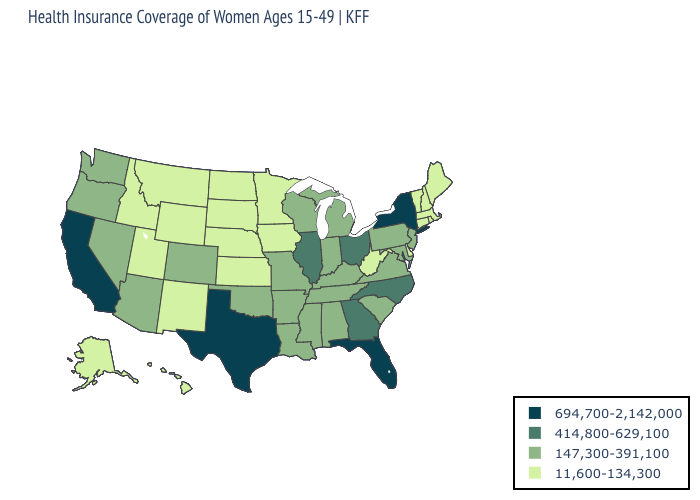Does Florida have the highest value in the South?
Be succinct. Yes. What is the value of Hawaii?
Short answer required. 11,600-134,300. Does Tennessee have the highest value in the South?
Short answer required. No. Does Illinois have a lower value than South Carolina?
Keep it brief. No. Does Maine have a lower value than Illinois?
Answer briefly. Yes. Does South Carolina have the lowest value in the South?
Keep it brief. No. Name the states that have a value in the range 11,600-134,300?
Short answer required. Alaska, Connecticut, Delaware, Hawaii, Idaho, Iowa, Kansas, Maine, Massachusetts, Minnesota, Montana, Nebraska, New Hampshire, New Mexico, North Dakota, Rhode Island, South Dakota, Utah, Vermont, West Virginia, Wyoming. Name the states that have a value in the range 147,300-391,100?
Quick response, please. Alabama, Arizona, Arkansas, Colorado, Indiana, Kentucky, Louisiana, Maryland, Michigan, Mississippi, Missouri, Nevada, New Jersey, Oklahoma, Oregon, Pennsylvania, South Carolina, Tennessee, Virginia, Washington, Wisconsin. Which states have the lowest value in the MidWest?
Be succinct. Iowa, Kansas, Minnesota, Nebraska, North Dakota, South Dakota. Name the states that have a value in the range 147,300-391,100?
Concise answer only. Alabama, Arizona, Arkansas, Colorado, Indiana, Kentucky, Louisiana, Maryland, Michigan, Mississippi, Missouri, Nevada, New Jersey, Oklahoma, Oregon, Pennsylvania, South Carolina, Tennessee, Virginia, Washington, Wisconsin. What is the highest value in the USA?
Short answer required. 694,700-2,142,000. Does Missouri have a lower value than Massachusetts?
Concise answer only. No. Which states have the lowest value in the South?
Keep it brief. Delaware, West Virginia. Does Texas have the highest value in the USA?
Write a very short answer. Yes. Does the first symbol in the legend represent the smallest category?
Keep it brief. No. 